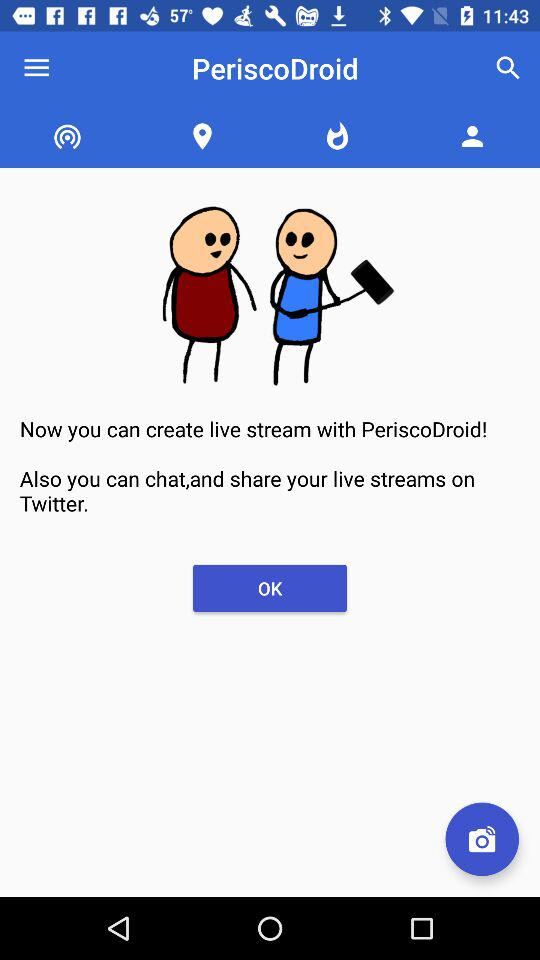Where is the user located?
When the provided information is insufficient, respond with <no answer>. <no answer> 